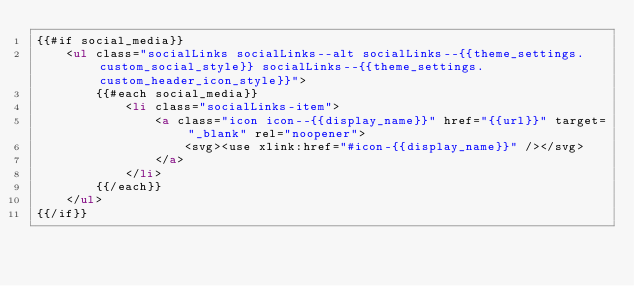Convert code to text. <code><loc_0><loc_0><loc_500><loc_500><_HTML_>{{#if social_media}}
    <ul class="socialLinks socialLinks--alt socialLinks--{{theme_settings.custom_social_style}} socialLinks--{{theme_settings.custom_header_icon_style}}">
        {{#each social_media}}
            <li class="socialLinks-item">
                <a class="icon icon--{{display_name}}" href="{{url}}" target="_blank" rel="noopener">
                    <svg><use xlink:href="#icon-{{display_name}}" /></svg>
                </a>
            </li>
        {{/each}}
    </ul>
{{/if}}
</code> 